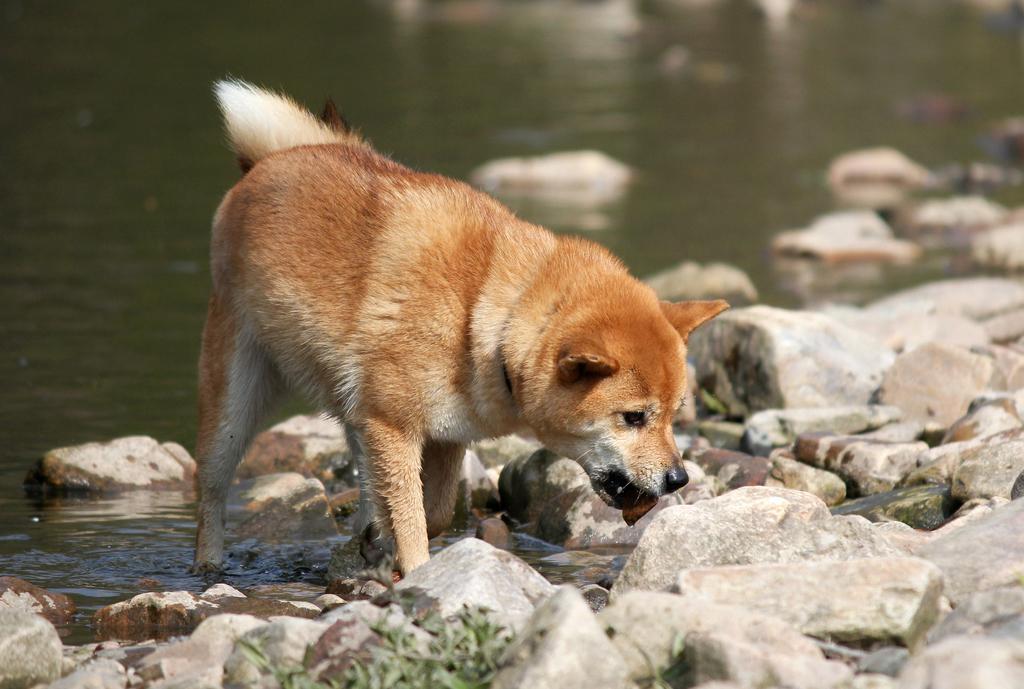Could you give a brief overview of what you see in this image? In this picture we can observe a dog standing in the water. The dog is in brown and white color. There are some stones here. We can observe plants. In the background there is some water. 